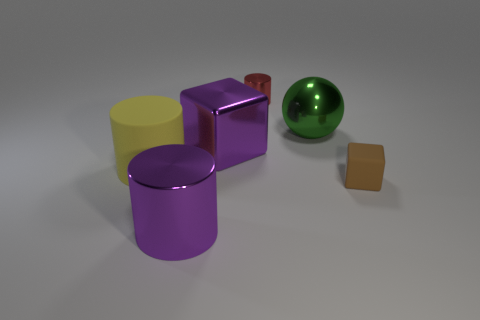Add 4 yellow metal balls. How many objects exist? 10 Subtract all large cylinders. How many cylinders are left? 1 Subtract all purple cubes. How many cubes are left? 1 Subtract all spheres. How many objects are left? 5 Subtract 1 cylinders. How many cylinders are left? 2 Subtract all green metallic cylinders. Subtract all shiny things. How many objects are left? 2 Add 1 red cylinders. How many red cylinders are left? 2 Add 3 tiny matte objects. How many tiny matte objects exist? 4 Subtract 0 red balls. How many objects are left? 6 Subtract all brown cylinders. Subtract all brown blocks. How many cylinders are left? 3 